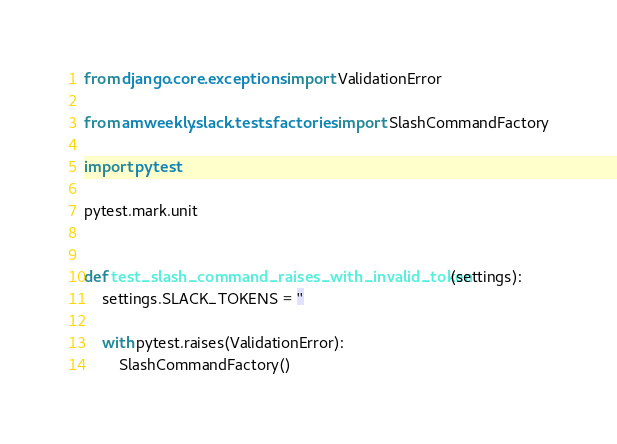Convert code to text. <code><loc_0><loc_0><loc_500><loc_500><_Python_>from django.core.exceptions import ValidationError

from amweekly.slack.tests.factories import SlashCommandFactory

import pytest

pytest.mark.unit


def test_slash_command_raises_with_invalid_token(settings):
    settings.SLACK_TOKENS = ''

    with pytest.raises(ValidationError):
        SlashCommandFactory()
</code> 